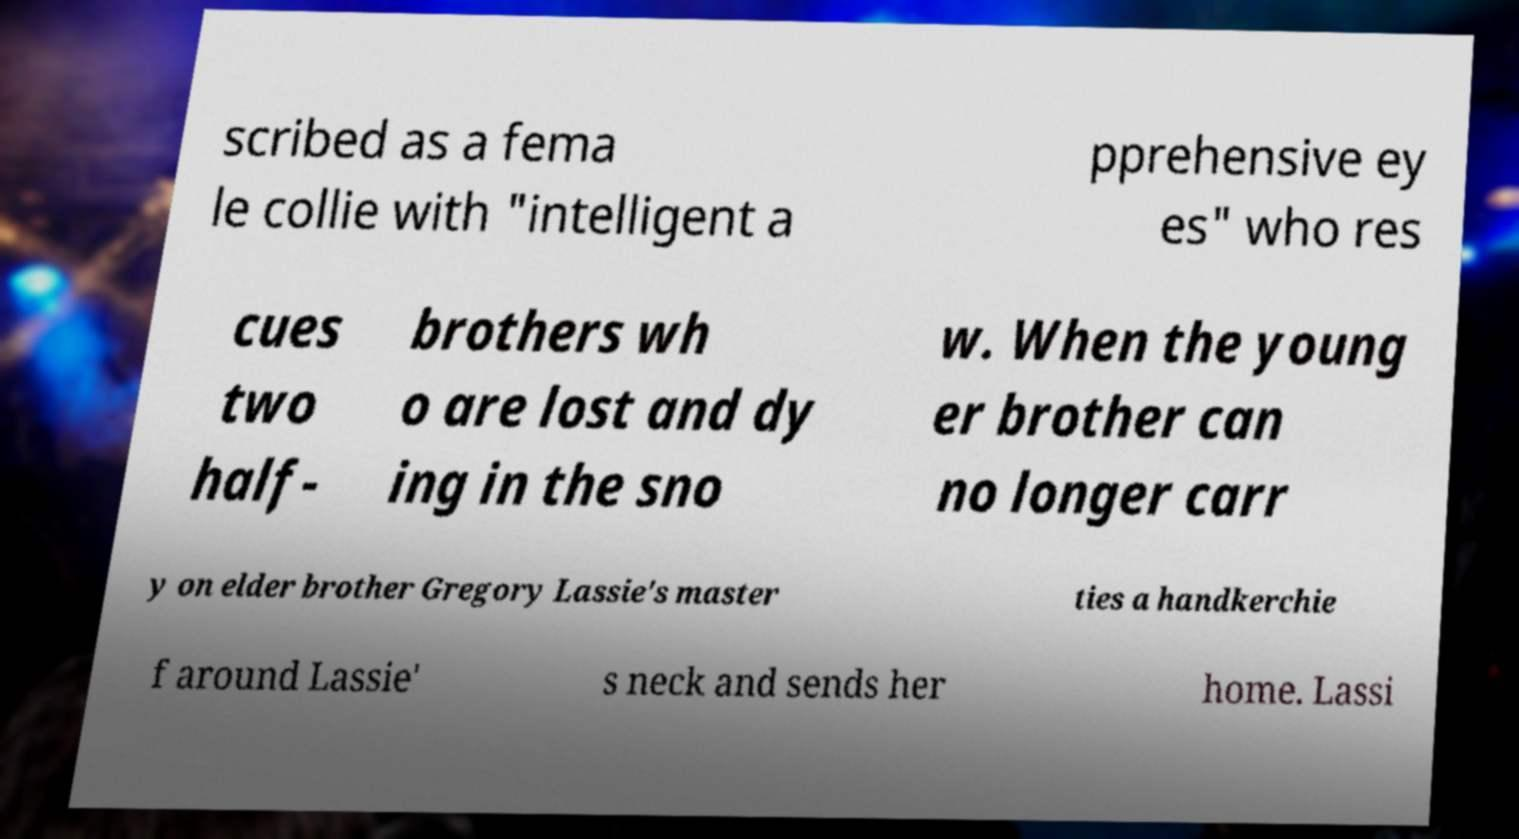Can you read and provide the text displayed in the image?This photo seems to have some interesting text. Can you extract and type it out for me? scribed as a fema le collie with "intelligent a pprehensive ey es" who res cues two half- brothers wh o are lost and dy ing in the sno w. When the young er brother can no longer carr y on elder brother Gregory Lassie's master ties a handkerchie f around Lassie' s neck and sends her home. Lassi 